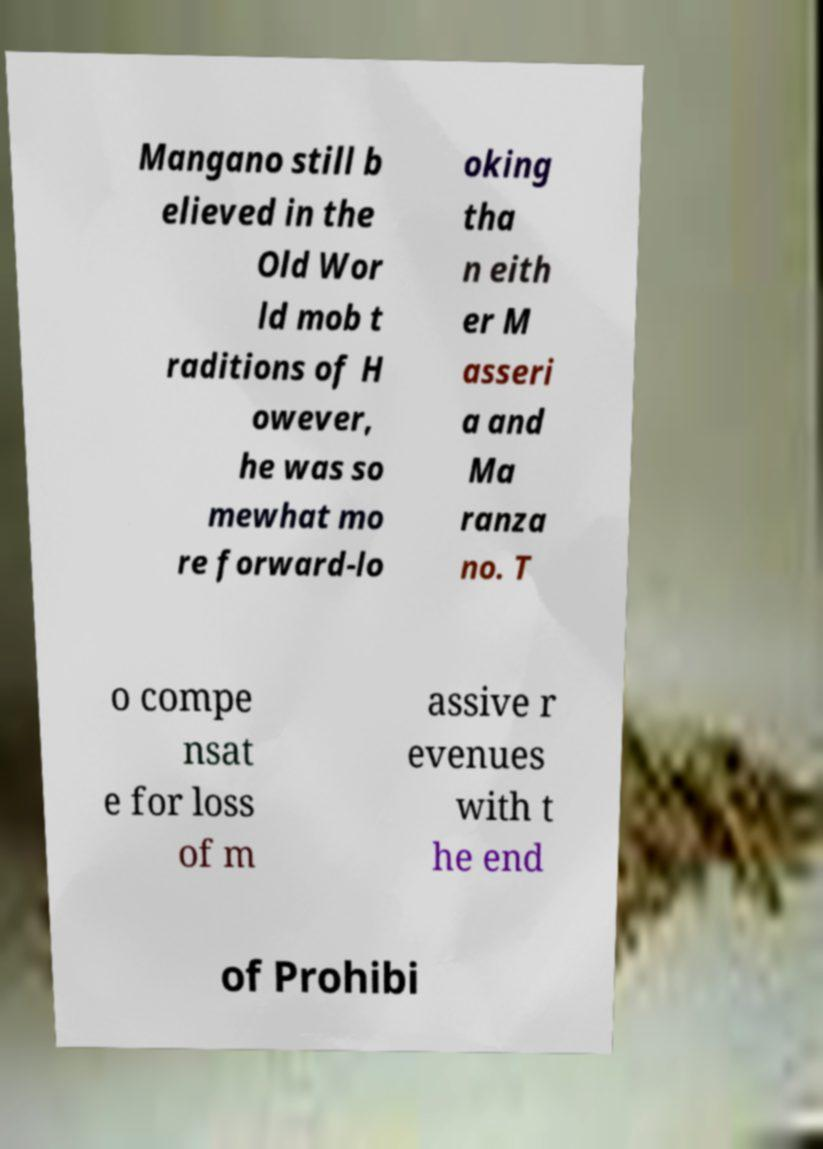For documentation purposes, I need the text within this image transcribed. Could you provide that? Mangano still b elieved in the Old Wor ld mob t raditions of H owever, he was so mewhat mo re forward-lo oking tha n eith er M asseri a and Ma ranza no. T o compe nsat e for loss of m assive r evenues with t he end of Prohibi 